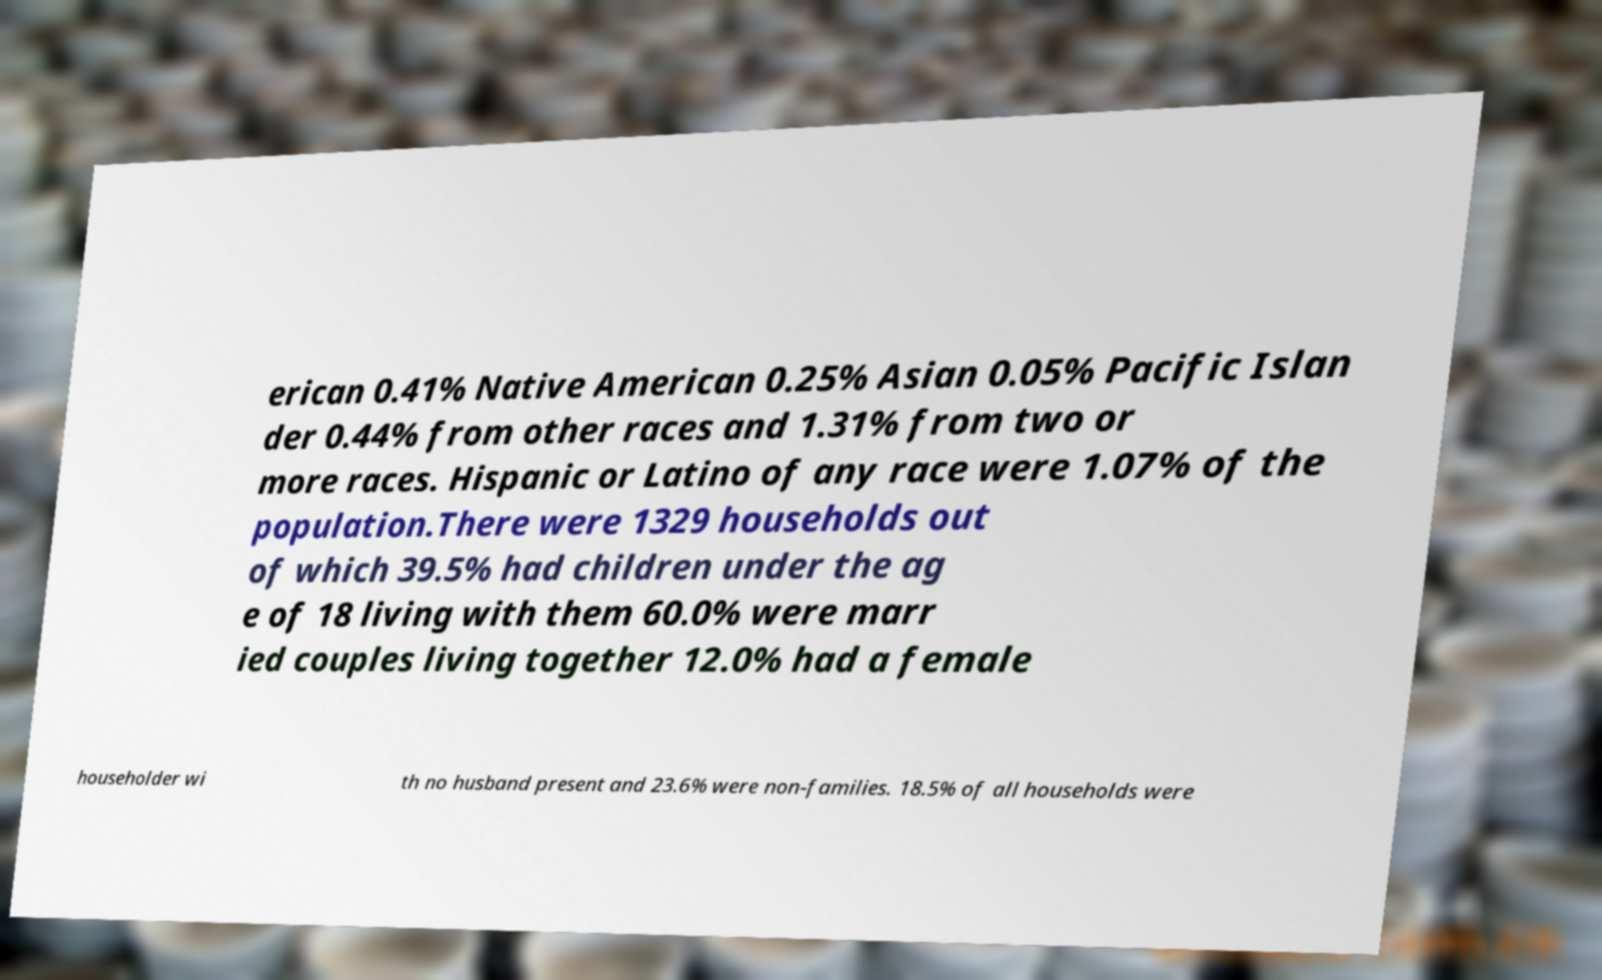There's text embedded in this image that I need extracted. Can you transcribe it verbatim? erican 0.41% Native American 0.25% Asian 0.05% Pacific Islan der 0.44% from other races and 1.31% from two or more races. Hispanic or Latino of any race were 1.07% of the population.There were 1329 households out of which 39.5% had children under the ag e of 18 living with them 60.0% were marr ied couples living together 12.0% had a female householder wi th no husband present and 23.6% were non-families. 18.5% of all households were 